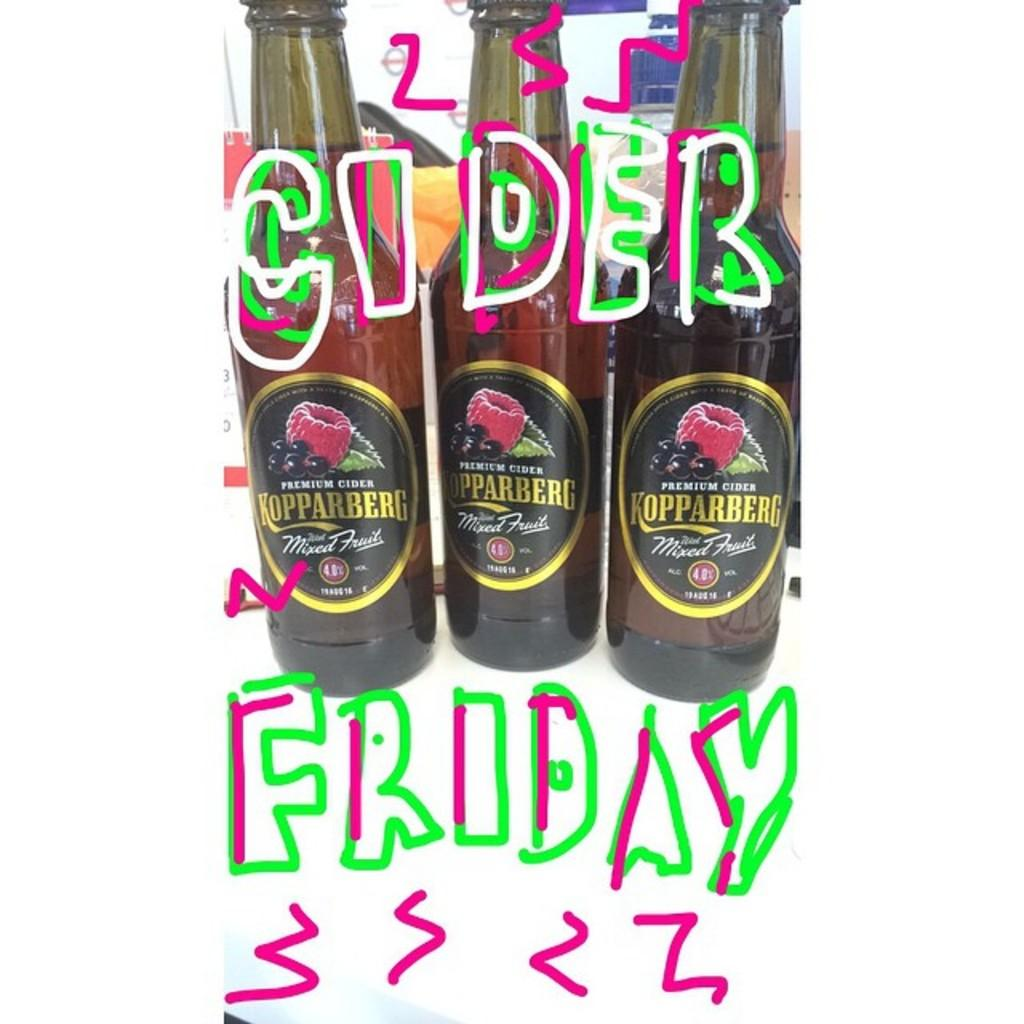<image>
Give a short and clear explanation of the subsequent image. Three bottles of Kopparberg sit next to each other. 